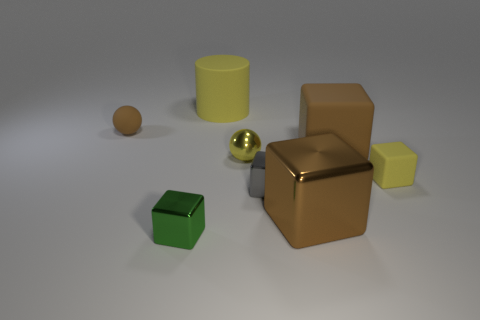Are there more brown shiny objects that are in front of the small green block than tiny yellow metal balls that are in front of the small matte cube?
Your response must be concise. No. What size is the other cube that is the same material as the tiny yellow cube?
Ensure brevity in your answer.  Large. There is a small brown object left of the small gray metal block; what number of large objects are to the left of it?
Offer a very short reply. 0. Are there any small yellow metallic objects of the same shape as the tiny yellow matte thing?
Your response must be concise. No. What is the color of the large block that is in front of the ball that is in front of the tiny brown rubber sphere?
Offer a very short reply. Brown. Are there more large green shiny things than large brown shiny objects?
Offer a very short reply. No. How many matte cubes have the same size as the gray thing?
Give a very brief answer. 1. Are the small gray block and the object to the left of the small green block made of the same material?
Offer a very short reply. No. Is the number of rubber things less than the number of brown metal cubes?
Ensure brevity in your answer.  No. Is there any other thing that has the same color as the tiny shiny ball?
Provide a short and direct response. Yes. 